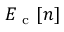<formula> <loc_0><loc_0><loc_500><loc_500>E _ { c } [ n ]</formula> 